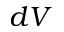<formula> <loc_0><loc_0><loc_500><loc_500>d V</formula> 